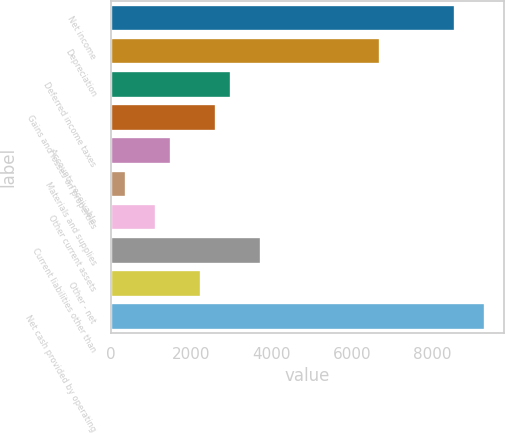<chart> <loc_0><loc_0><loc_500><loc_500><bar_chart><fcel>Net income<fcel>Depreciation<fcel>Deferred income taxes<fcel>Gains and losses on properties<fcel>Accounts receivable<fcel>Materials and supplies<fcel>Other current assets<fcel>Current liabilities other than<fcel>Other - net<fcel>Net cash provided by operating<nl><fcel>8556.8<fcel>6698.8<fcel>2982.8<fcel>2611.2<fcel>1496.4<fcel>381.6<fcel>1124.8<fcel>3726<fcel>2239.6<fcel>9300<nl></chart> 